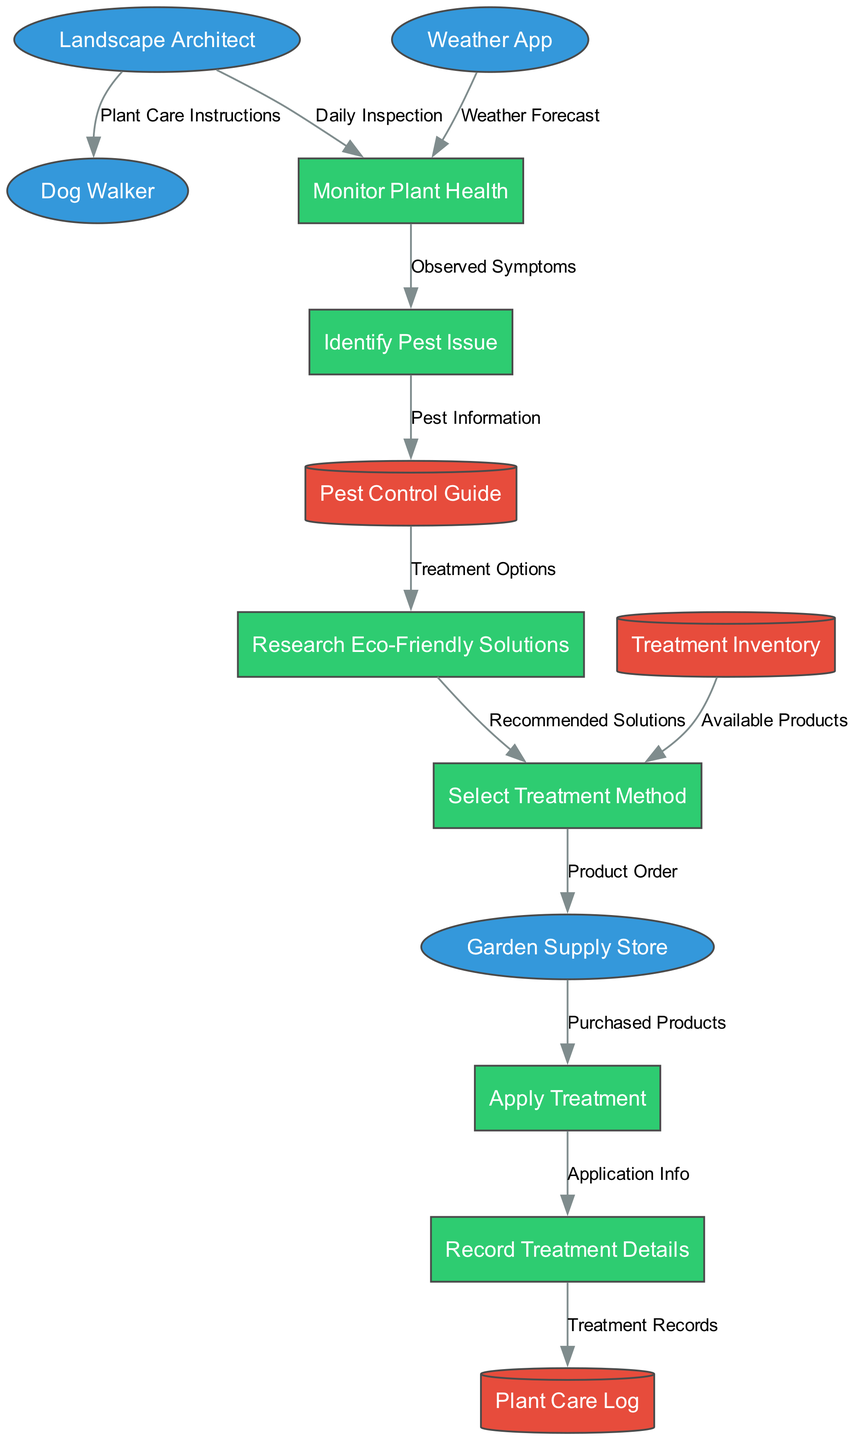What are the external entities involved in this process? The diagram lists four external entities: Landscape Architect, Garden Supply Store, Dog Walker, and Weather App. These entities interact with the processes and stores within the pest control process.
Answer: Landscape Architect, Garden Supply Store, Dog Walker, Weather App How many processes are defined in the diagram? The diagram contains six processes related to garden pest control: Monitor Plant Health, Identify Pest Issue, Research Eco-Friendly Solutions, Select Treatment Method, Apply Treatment, and Record Treatment Details.
Answer: 6 Which process directly follows "Monitor Plant Health"? After "Monitor Plant Health", the next process is "Identify Pest Issue". This indicates that once the plant's health is monitored, identifying any pest issues is the immediate next step.
Answer: Identify Pest Issue What information does the "Identify Pest Issue" process send to the "Pest Control Guide"? The "Identify Pest Issue" process sends "Pest Information" to the "Pest Control Guide". This indicates that the findings from identifying the pest issue are recorded and referenced for treatment guidance.
Answer: Pest Information How many data stores are there in the diagram? The diagram features three data stores: Plant Care Log, Pest Control Guide, and Treatment Inventory. These stores help in managing the records and information necessary for effective pest control.
Answer: 3 Which step comes before selecting a treatment method? The step that comes before selecting a treatment method is "Research Eco-Friendly Solutions". This implies that the recommended solutions from the research phase are necessary prior to making a selection.
Answer: Research Eco-Friendly Solutions What does the "Apply Treatment" process receive from the "Garden Supply Store"? The "Apply Treatment" process receives "Purchased Products" from the "Garden Supply Store". This indicates that the treatment application depends on the products acquired for pest control.
Answer: Purchased Products How many edges connect the external entities to the processes? There are five edges connecting the external entities to the processes in the diagram. These edges represent the flow of information from external sources to the internal processes.
Answer: 5 What is recorded after applying the treatment? After applying the treatment, the "Record Treatment Details" process records "Application Info". This means that details regarding the treatment application are documented following its execution.
Answer: Application Info 